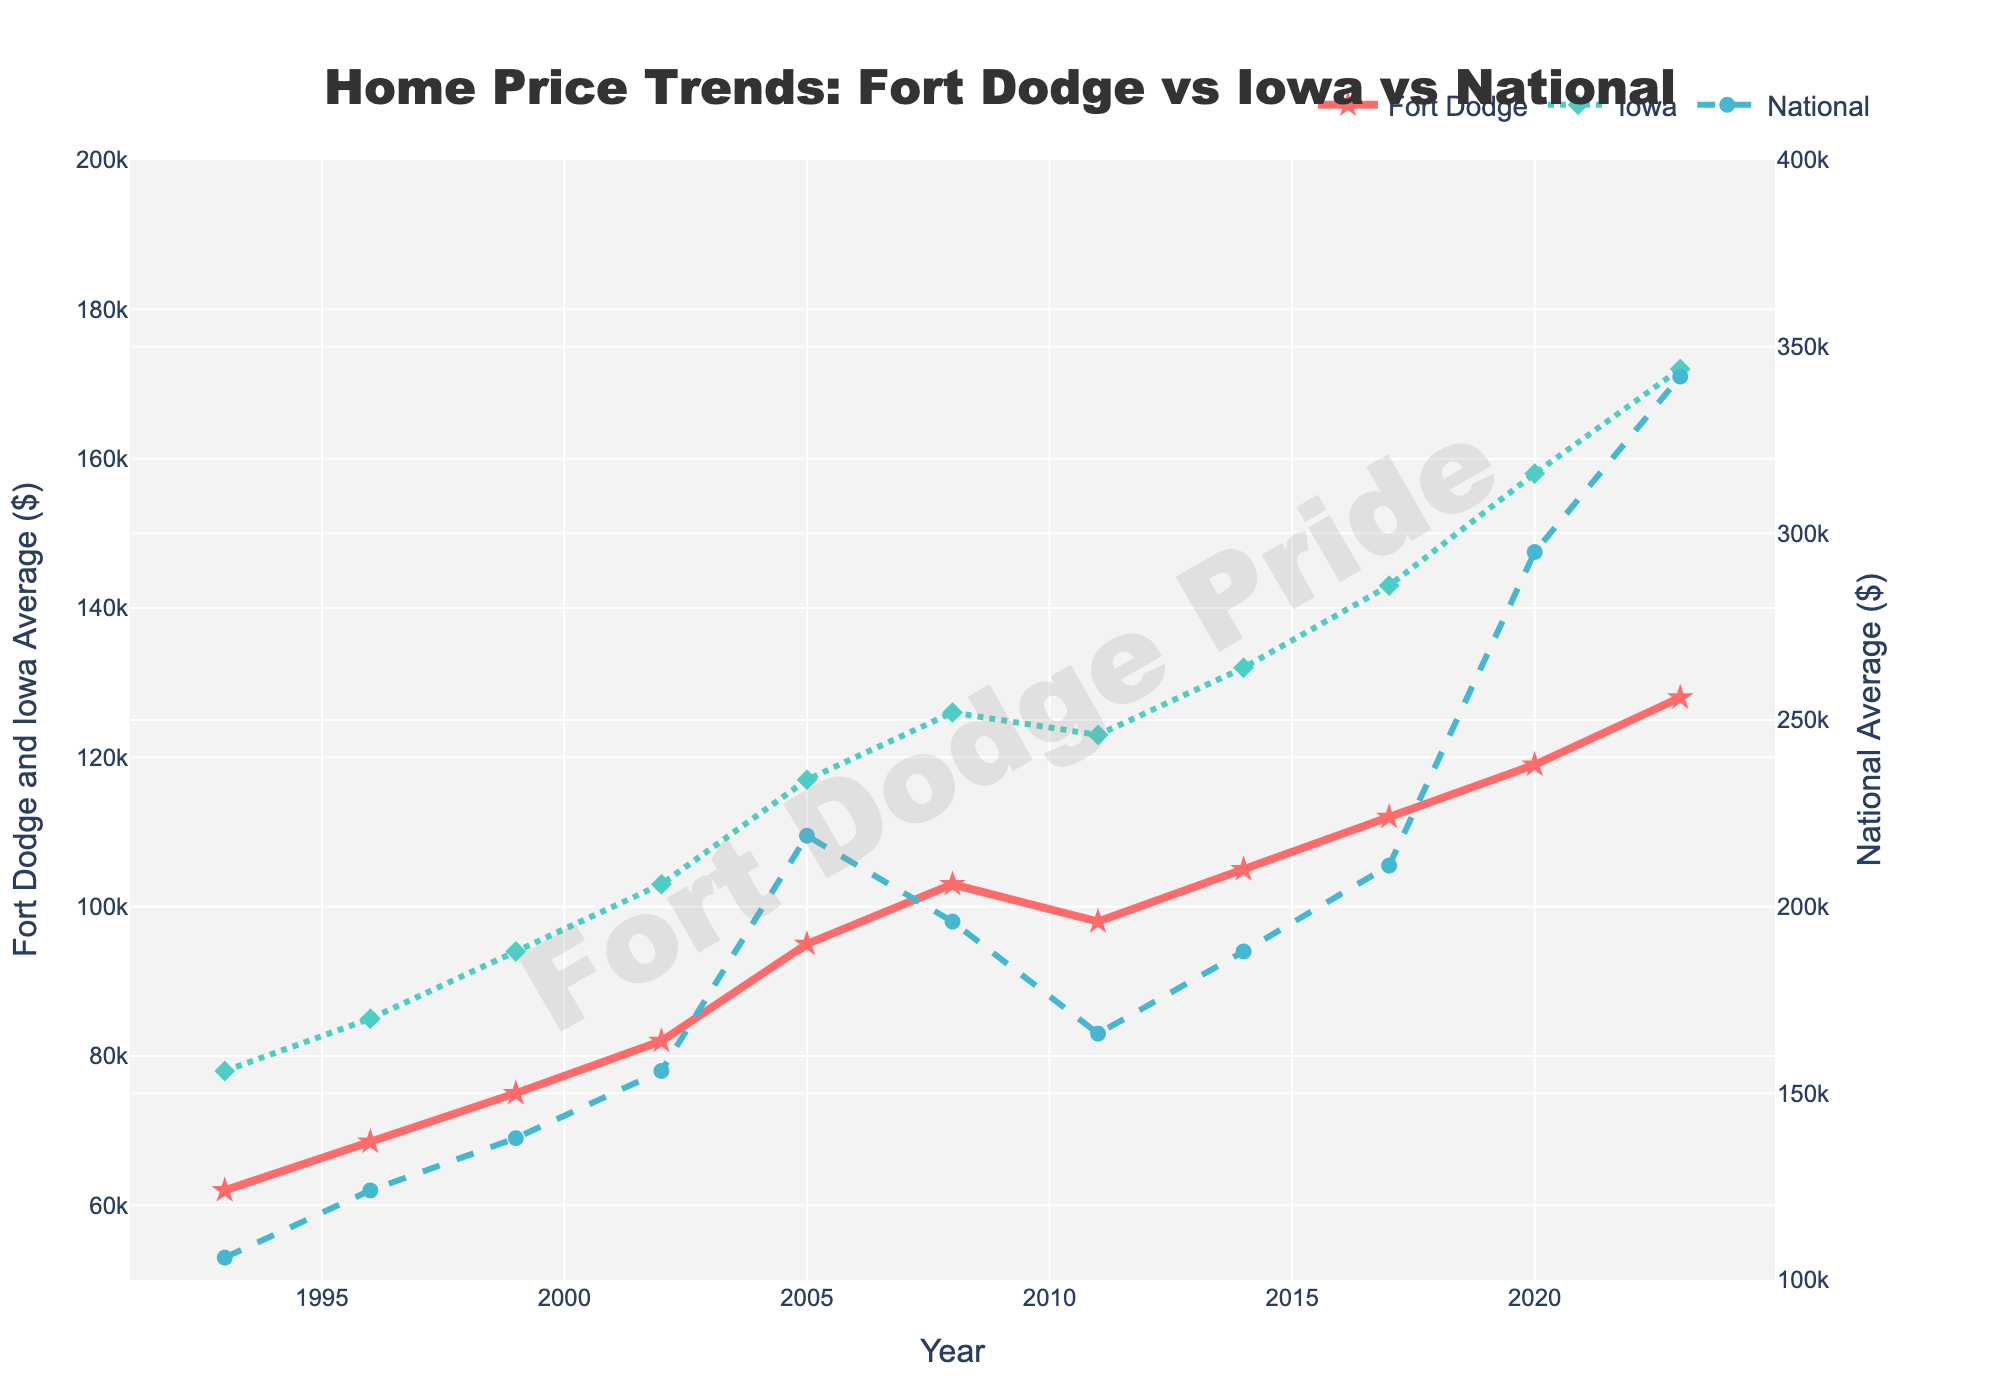What is the trend of home prices in Fort Dodge over the last 30 years? The trend can be observed by following the "Fort Dodge" line on the plot from 1993 to 2023. Home prices in Fort Dodge have shown a consistent increase from $62,000 in 1993 to $128,000 in 2023.
Answer: An increasing trend How do the average home prices in Fort Dodge in 1993 compare to those in Iowa and across the nation? In 1993, the plot shows that Fort Dodge's average home price was $62,000, while Iowa's average was $78,000, and the national average was $106,000. By comparison, Fort Dodge had the lowest home prices among the three.
Answer: Fort Dodge had the lowest home prices Which year did Fort Dodge experience the highest average home price, and what was the value? To find this, we need to look at the peak of the "Fort Dodge" line. The highest average home price for Fort Dodge is seen in 2023, at $128,000.
Answer: 2023, $128,000 In which time period did the national average home price see the most significant increase? By observing the "National" line, we can see that the most significant increase occurred between 2017 and 2020, where prices skyrocketed from $211,000 to $295,000.
Answer: 2017-2020 How did Fort Dodge's average home price change from 2008 to 2011? The plot shows a decrease from $103,000 in 2008 to $98,000 in 2011. To find the change: $98,000 - $103,000 = -$5,000.
Answer: Decreased by $5,000 What was the difference between Iowa's average home price and the national average home price in 2023? In 2023, Iowa's average home price was $172,000, and the national average was $342,000. The difference is $342,000 - $172,000 = $170,000.
Answer: $170,000 Compare the growth rate of home prices in Fort Dodge and Iowa from 1993 to 2023. In 1993, Fort Dodge's average home price was $62,000 and increased to $128,000 in 2023, a growth of $128,000 - $62,000 = $66,000. For Iowa, the price increased from $78,000 to $172,000, a growth of $172,000 - $78,000 = $94,000. Thus, Iowa experienced a greater growth.
Answer: Iowa experienced greater growth What visual elements indicate the periods of housing market downturns? Periods of downturn are represented by downward slopes in the lines. For instance, Fort Dodge's line shows a downturn from 2008 to 2011.
Answer: Downward slopes in the lines During which years were the home prices in Fort Dodge higher than the Iowa state average? Examining the plot, there was no period where Fort Dodge's average home prices surpassed Iowa's average home prices from 1993 to 2023.
Answer: None 